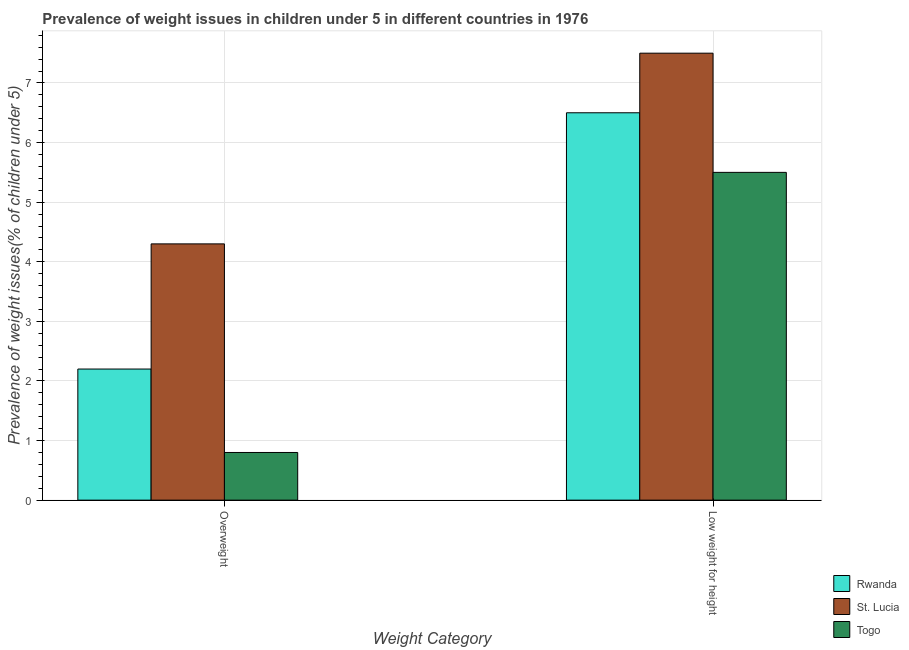How many different coloured bars are there?
Your answer should be compact. 3. How many bars are there on the 1st tick from the left?
Give a very brief answer. 3. What is the label of the 1st group of bars from the left?
Offer a terse response. Overweight. What is the percentage of underweight children in St. Lucia?
Give a very brief answer. 7.5. Across all countries, what is the maximum percentage of overweight children?
Your answer should be very brief. 4.3. Across all countries, what is the minimum percentage of overweight children?
Provide a short and direct response. 0.8. In which country was the percentage of overweight children maximum?
Offer a very short reply. St. Lucia. In which country was the percentage of overweight children minimum?
Make the answer very short. Togo. What is the difference between the percentage of overweight children in Togo and that in Rwanda?
Provide a succinct answer. -1.4. What is the difference between the percentage of overweight children in Togo and the percentage of underweight children in Rwanda?
Your response must be concise. -5.7. What is the average percentage of overweight children per country?
Your response must be concise. 2.43. What is the difference between the percentage of overweight children and percentage of underweight children in Rwanda?
Your response must be concise. -4.3. What is the ratio of the percentage of underweight children in St. Lucia to that in Rwanda?
Offer a very short reply. 1.15. Is the percentage of underweight children in Togo less than that in St. Lucia?
Provide a short and direct response. Yes. What does the 3rd bar from the left in Overweight represents?
Your response must be concise. Togo. What does the 1st bar from the right in Low weight for height represents?
Provide a succinct answer. Togo. How many bars are there?
Keep it short and to the point. 6. How many countries are there in the graph?
Your response must be concise. 3. Are the values on the major ticks of Y-axis written in scientific E-notation?
Keep it short and to the point. No. Does the graph contain grids?
Provide a short and direct response. Yes. Where does the legend appear in the graph?
Your response must be concise. Bottom right. How many legend labels are there?
Your response must be concise. 3. How are the legend labels stacked?
Provide a succinct answer. Vertical. What is the title of the graph?
Ensure brevity in your answer.  Prevalence of weight issues in children under 5 in different countries in 1976. Does "East Asia (all income levels)" appear as one of the legend labels in the graph?
Your answer should be very brief. No. What is the label or title of the X-axis?
Offer a terse response. Weight Category. What is the label or title of the Y-axis?
Provide a short and direct response. Prevalence of weight issues(% of children under 5). What is the Prevalence of weight issues(% of children under 5) of Rwanda in Overweight?
Your answer should be very brief. 2.2. What is the Prevalence of weight issues(% of children under 5) in St. Lucia in Overweight?
Provide a short and direct response. 4.3. What is the Prevalence of weight issues(% of children under 5) in Togo in Overweight?
Give a very brief answer. 0.8. What is the Prevalence of weight issues(% of children under 5) in Rwanda in Low weight for height?
Give a very brief answer. 6.5. What is the Prevalence of weight issues(% of children under 5) of St. Lucia in Low weight for height?
Offer a very short reply. 7.5. What is the Prevalence of weight issues(% of children under 5) in Togo in Low weight for height?
Your answer should be compact. 5.5. Across all Weight Category, what is the maximum Prevalence of weight issues(% of children under 5) of St. Lucia?
Give a very brief answer. 7.5. Across all Weight Category, what is the minimum Prevalence of weight issues(% of children under 5) of Rwanda?
Give a very brief answer. 2.2. Across all Weight Category, what is the minimum Prevalence of weight issues(% of children under 5) of St. Lucia?
Offer a very short reply. 4.3. Across all Weight Category, what is the minimum Prevalence of weight issues(% of children under 5) in Togo?
Offer a very short reply. 0.8. What is the total Prevalence of weight issues(% of children under 5) in St. Lucia in the graph?
Your response must be concise. 11.8. What is the difference between the Prevalence of weight issues(% of children under 5) in Rwanda in Overweight and that in Low weight for height?
Offer a very short reply. -4.3. What is the difference between the Prevalence of weight issues(% of children under 5) of St. Lucia in Overweight and that in Low weight for height?
Keep it short and to the point. -3.2. What is the difference between the Prevalence of weight issues(% of children under 5) in Rwanda in Overweight and the Prevalence of weight issues(% of children under 5) in St. Lucia in Low weight for height?
Your response must be concise. -5.3. What is the difference between the Prevalence of weight issues(% of children under 5) of Rwanda in Overweight and the Prevalence of weight issues(% of children under 5) of Togo in Low weight for height?
Keep it short and to the point. -3.3. What is the average Prevalence of weight issues(% of children under 5) of Rwanda per Weight Category?
Offer a terse response. 4.35. What is the average Prevalence of weight issues(% of children under 5) in St. Lucia per Weight Category?
Your response must be concise. 5.9. What is the average Prevalence of weight issues(% of children under 5) of Togo per Weight Category?
Make the answer very short. 3.15. What is the difference between the Prevalence of weight issues(% of children under 5) in Rwanda and Prevalence of weight issues(% of children under 5) in St. Lucia in Overweight?
Offer a very short reply. -2.1. What is the difference between the Prevalence of weight issues(% of children under 5) in Rwanda and Prevalence of weight issues(% of children under 5) in Togo in Low weight for height?
Ensure brevity in your answer.  1. What is the ratio of the Prevalence of weight issues(% of children under 5) of Rwanda in Overweight to that in Low weight for height?
Make the answer very short. 0.34. What is the ratio of the Prevalence of weight issues(% of children under 5) in St. Lucia in Overweight to that in Low weight for height?
Provide a succinct answer. 0.57. What is the ratio of the Prevalence of weight issues(% of children under 5) of Togo in Overweight to that in Low weight for height?
Your answer should be very brief. 0.15. What is the difference between the highest and the second highest Prevalence of weight issues(% of children under 5) in Rwanda?
Offer a very short reply. 4.3. What is the difference between the highest and the second highest Prevalence of weight issues(% of children under 5) of St. Lucia?
Make the answer very short. 3.2. What is the difference between the highest and the second highest Prevalence of weight issues(% of children under 5) of Togo?
Ensure brevity in your answer.  4.7. What is the difference between the highest and the lowest Prevalence of weight issues(% of children under 5) in Togo?
Your answer should be compact. 4.7. 